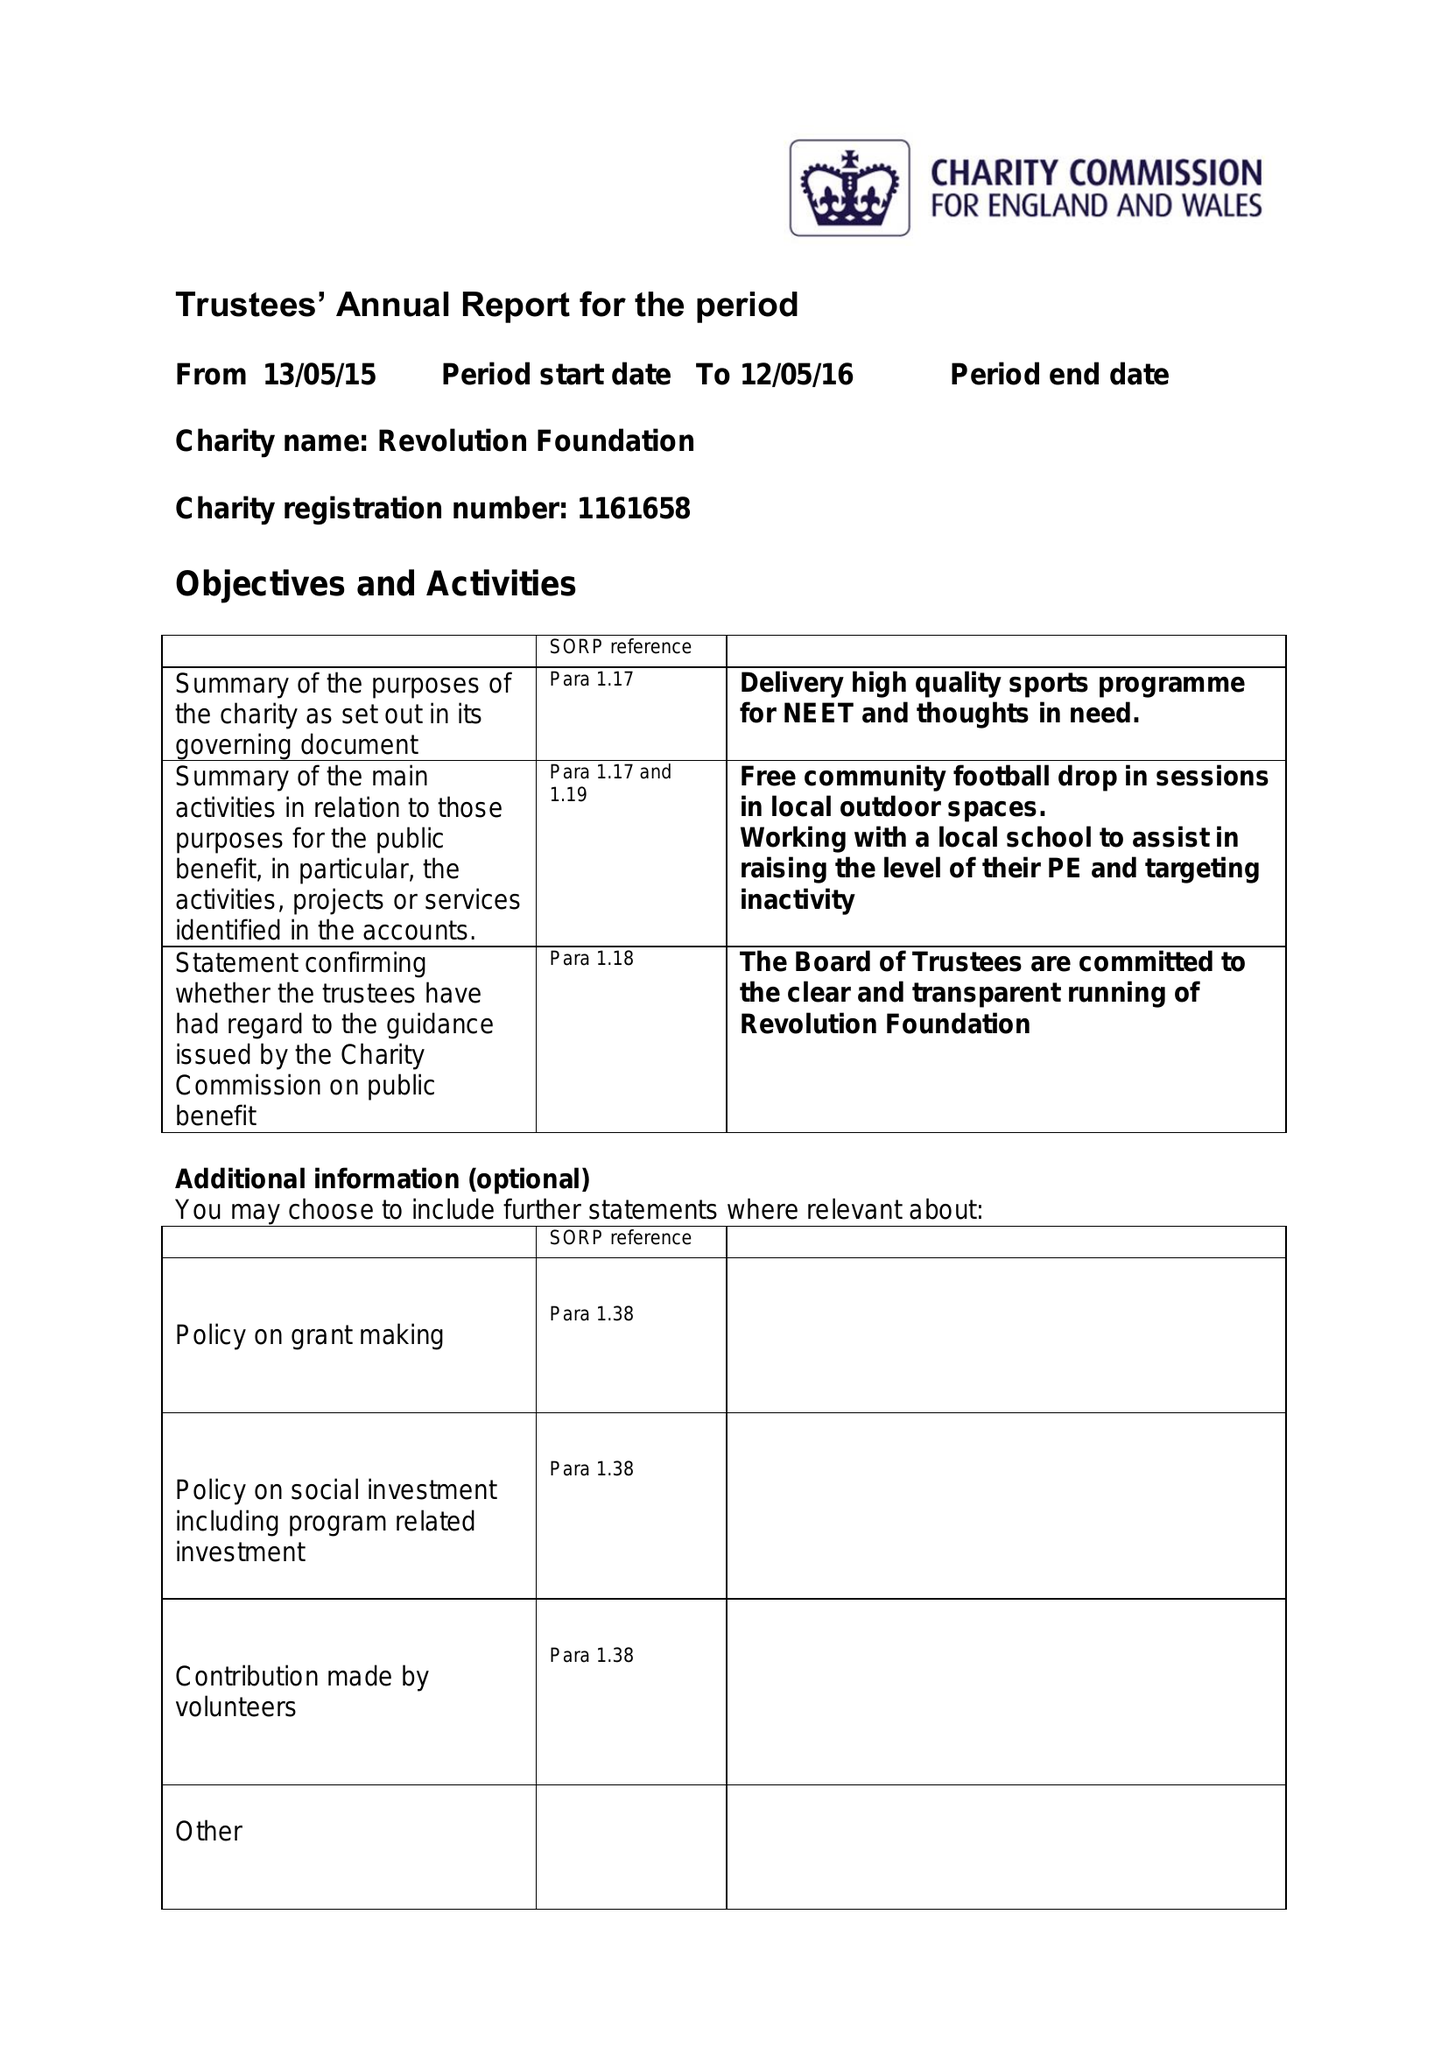What is the value for the charity_number?
Answer the question using a single word or phrase. 1161658 